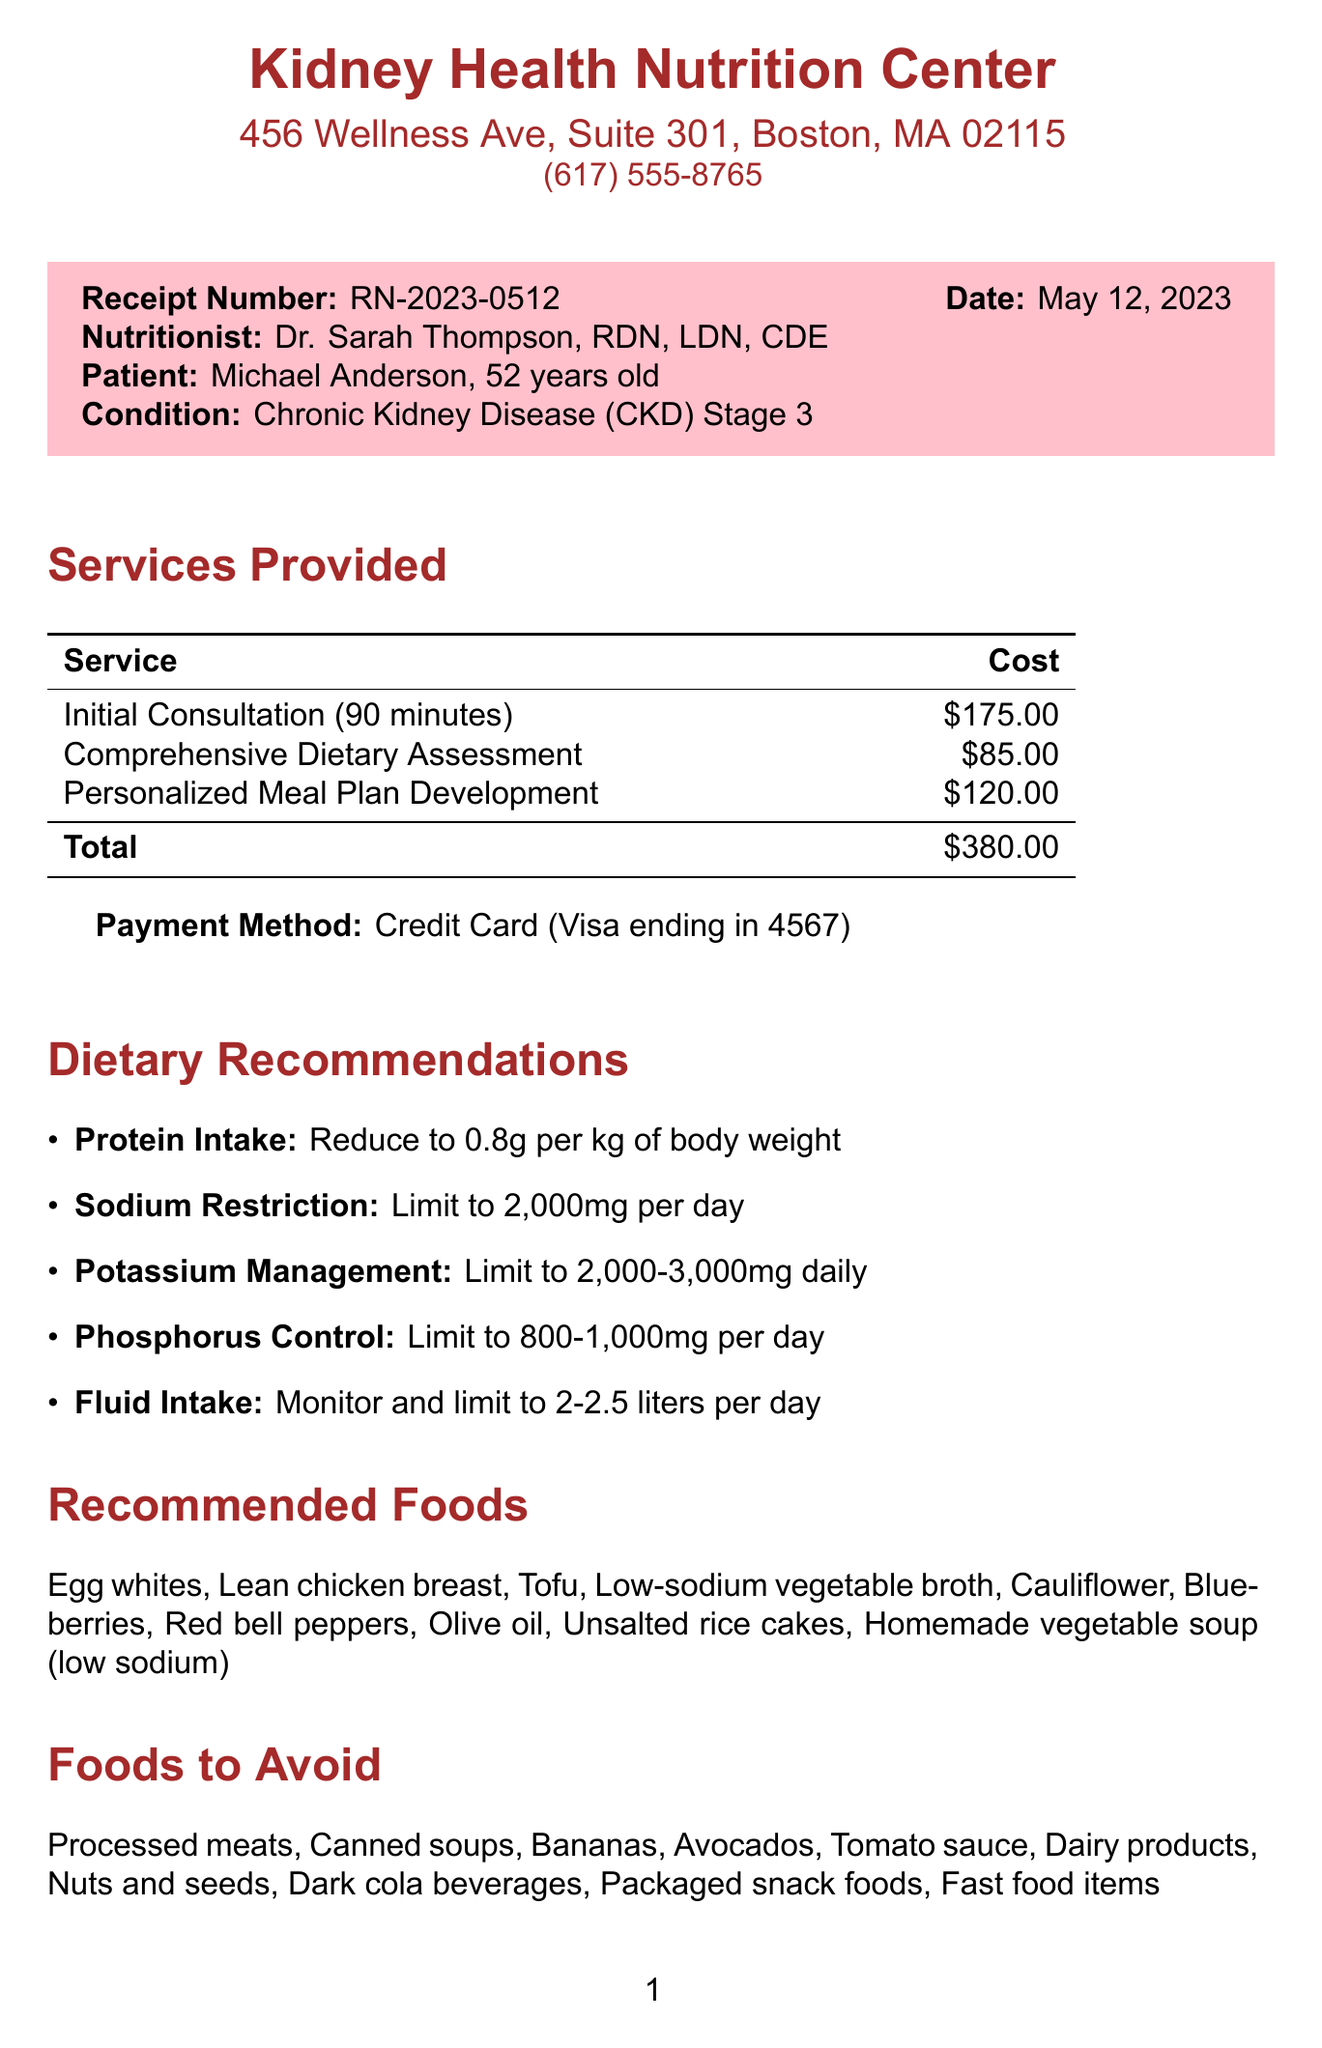What is the receipt number? The receipt number is specified at the top of the document for reference.
Answer: RN-2023-0512 Who is the nutritionist? The document lists the name and credentials of the nutritionist providing the consultation.
Answer: Dr. Sarah Thompson What is the patient's age? The age of the patient is mentioned in the patient section of the document.
Answer: 52 How long was the initial consultation? The duration of the initial consultation is stated in the services provided section.
Answer: 90 minutes What is the recommended sodium intake limit? The document provides specific dietary recommendations including limits for sodium intake.
Answer: 2,000mg per day What total cost is listed on the receipt? The total cost sums all provided services, found at the end of the services provided section.
Answer: $380.00 What foods should be avoided? The foods to avoid are listed explicitly in a section of the document.
Answer: Processed meats When is the follow-up appointment recommended? The document specifies the timeframe for scheduling a follow-up appointment.
Answer: In 4 weeks What should be monitored for fluid intake? The document recommends a measurement related to fluid intake.
Answer: Limit to 2-2.5 liters per day 